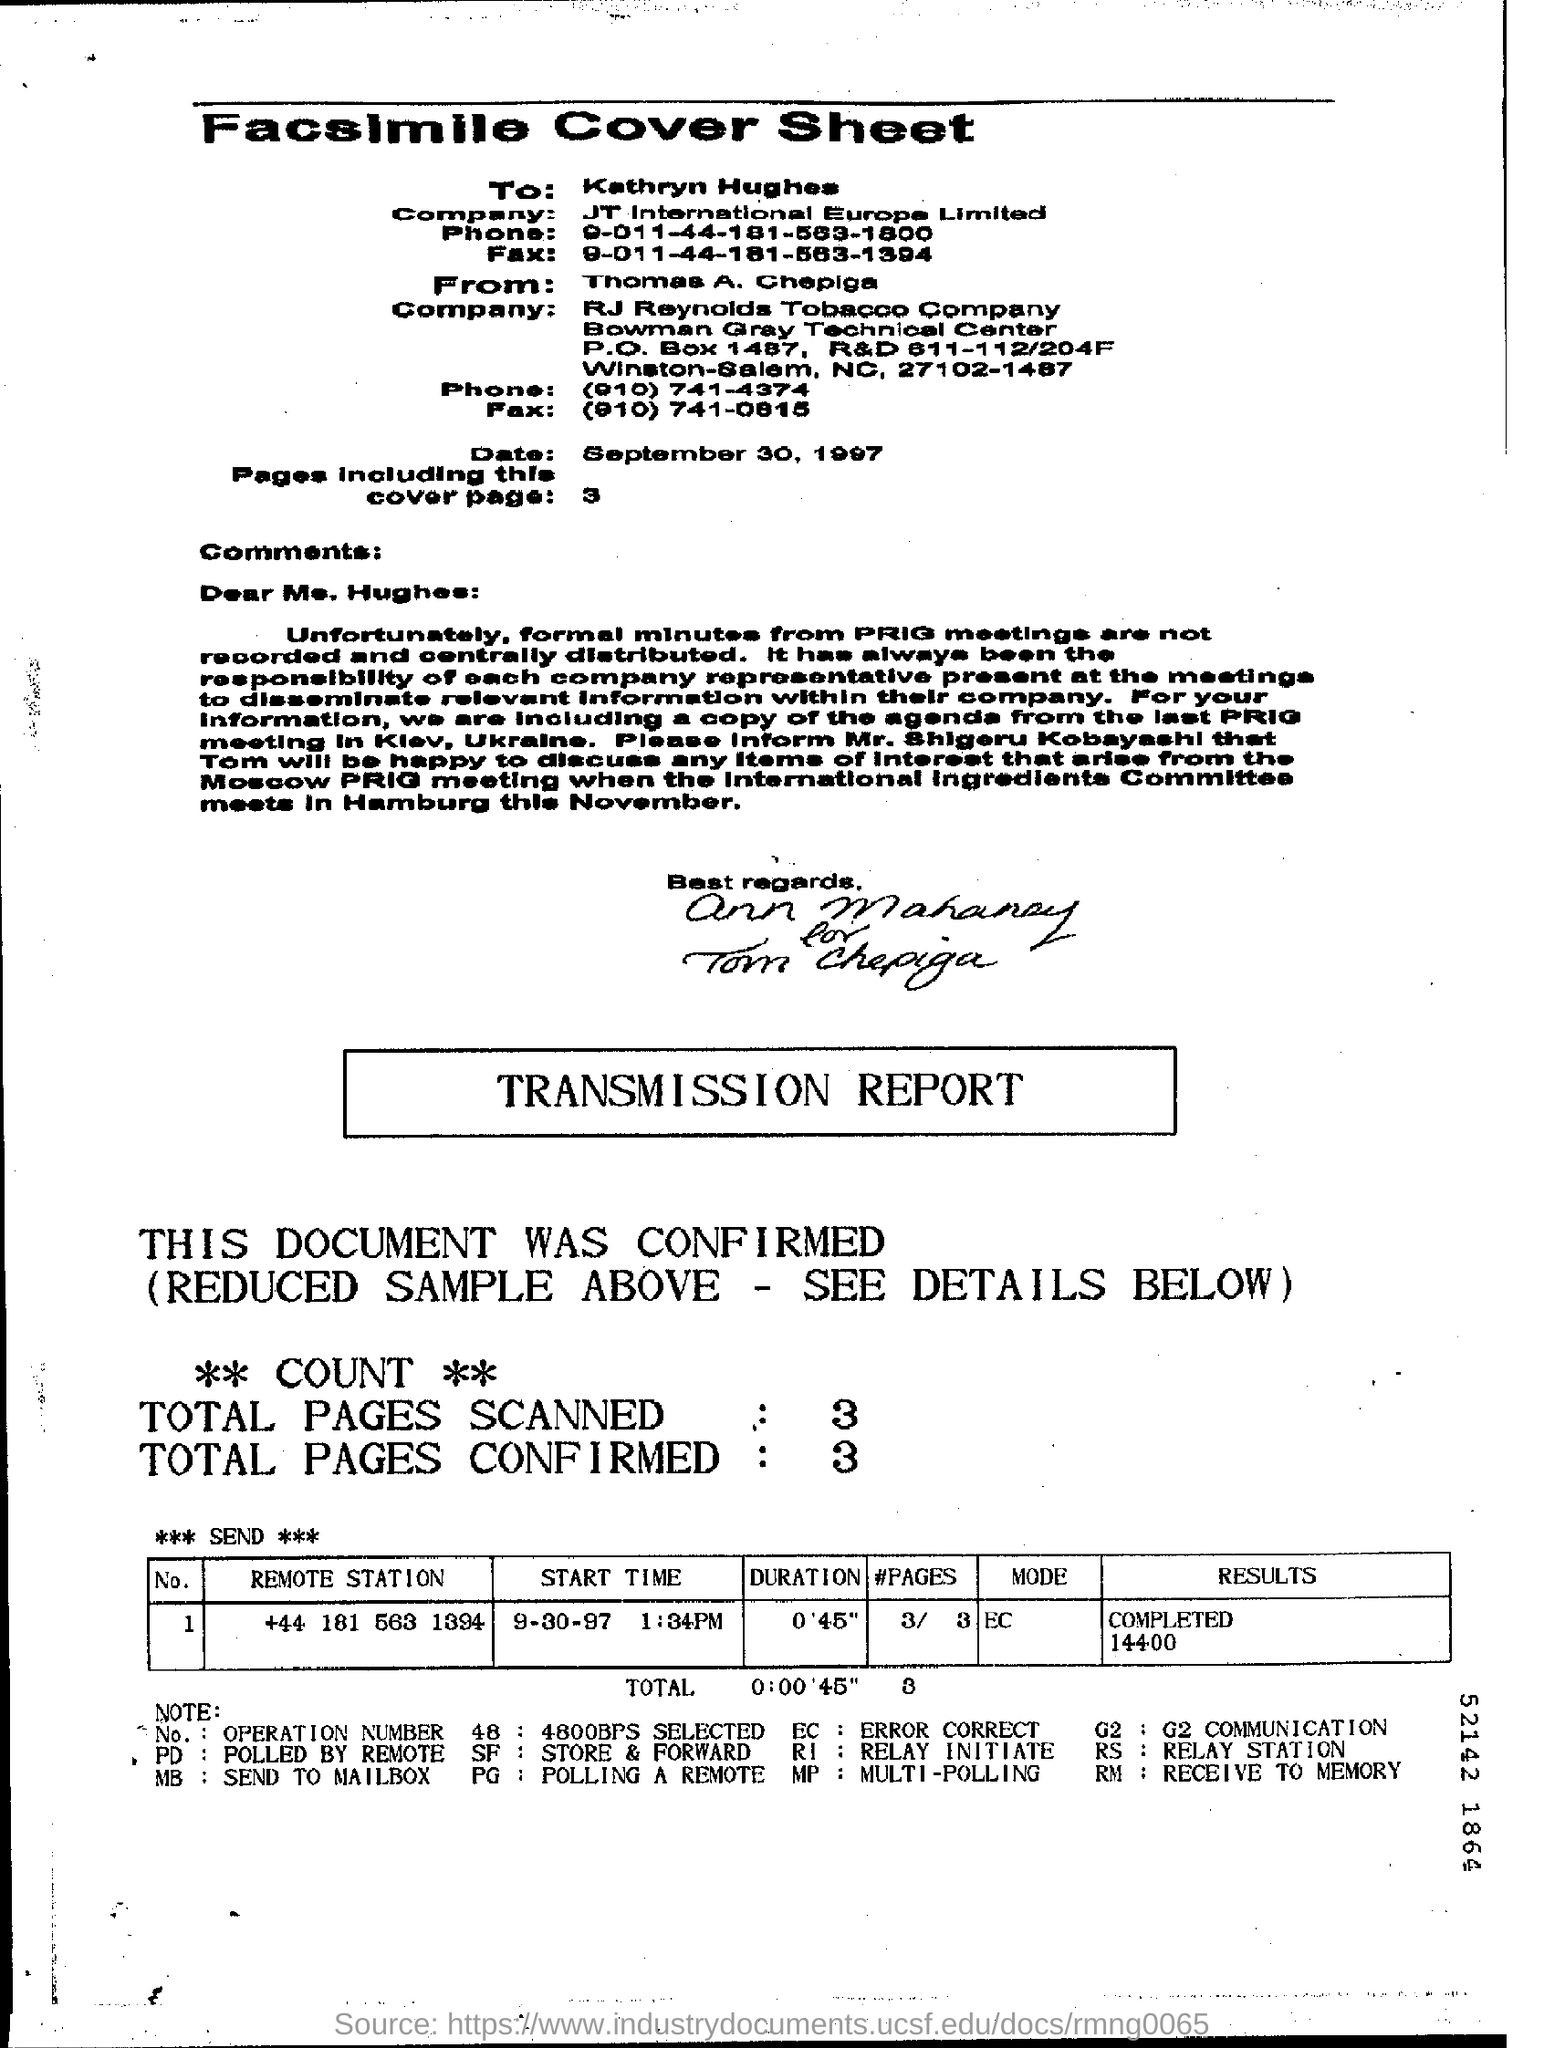What is the Heading of this page
Make the answer very short. Facsimile Cover Sheet. 